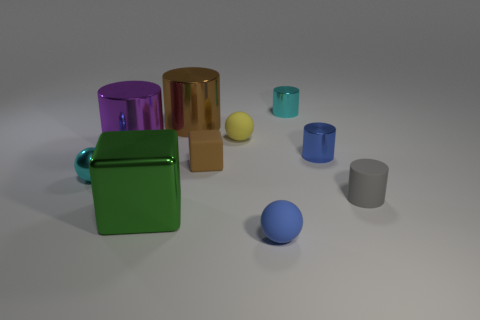Subtract all big brown cylinders. How many cylinders are left? 4 Subtract all green cylinders. Subtract all red spheres. How many cylinders are left? 5 Subtract all spheres. How many objects are left? 7 Add 9 tiny blue shiny objects. How many tiny blue shiny objects are left? 10 Add 8 small purple matte cubes. How many small purple matte cubes exist? 8 Subtract 0 red cylinders. How many objects are left? 10 Subtract all rubber cubes. Subtract all metallic cylinders. How many objects are left? 5 